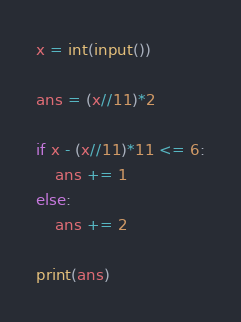<code> <loc_0><loc_0><loc_500><loc_500><_Python_>x = int(input())

ans = (x//11)*2

if x - (x//11)*11 <= 6:
    ans += 1
else:
    ans += 2

print(ans)</code> 